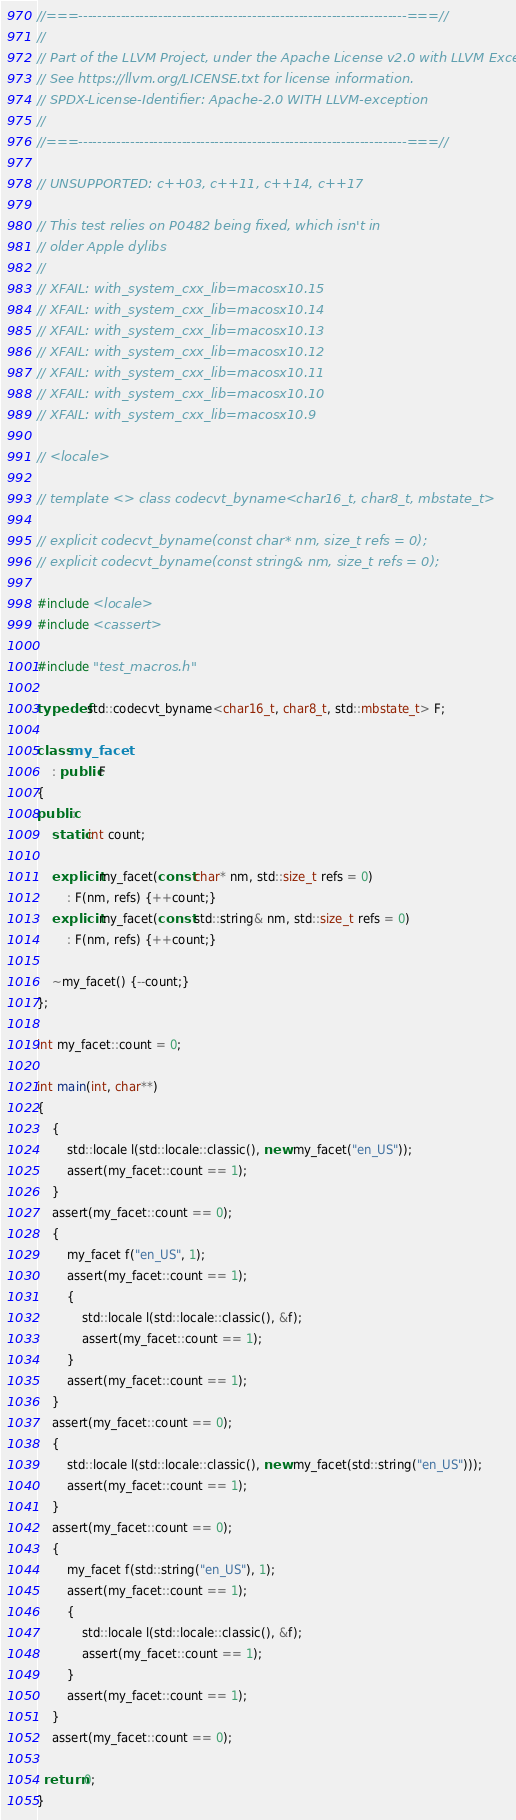<code> <loc_0><loc_0><loc_500><loc_500><_C++_>//===----------------------------------------------------------------------===//
//
// Part of the LLVM Project, under the Apache License v2.0 with LLVM Exceptions.
// See https://llvm.org/LICENSE.txt for license information.
// SPDX-License-Identifier: Apache-2.0 WITH LLVM-exception
//
//===----------------------------------------------------------------------===//

// UNSUPPORTED: c++03, c++11, c++14, c++17

// This test relies on P0482 being fixed, which isn't in
// older Apple dylibs
//
// XFAIL: with_system_cxx_lib=macosx10.15
// XFAIL: with_system_cxx_lib=macosx10.14
// XFAIL: with_system_cxx_lib=macosx10.13
// XFAIL: with_system_cxx_lib=macosx10.12
// XFAIL: with_system_cxx_lib=macosx10.11
// XFAIL: with_system_cxx_lib=macosx10.10
// XFAIL: with_system_cxx_lib=macosx10.9 

// <locale>

// template <> class codecvt_byname<char16_t, char8_t, mbstate_t>

// explicit codecvt_byname(const char* nm, size_t refs = 0);
// explicit codecvt_byname(const string& nm, size_t refs = 0);

#include <locale>
#include <cassert>

#include "test_macros.h"

typedef std::codecvt_byname<char16_t, char8_t, std::mbstate_t> F;

class my_facet
    : public F
{
public:
    static int count;

    explicit my_facet(const char* nm, std::size_t refs = 0)
        : F(nm, refs) {++count;}
    explicit my_facet(const std::string& nm, std::size_t refs = 0)
        : F(nm, refs) {++count;}

    ~my_facet() {--count;}
};

int my_facet::count = 0;

int main(int, char**)
{
    {
        std::locale l(std::locale::classic(), new my_facet("en_US"));
        assert(my_facet::count == 1);
    }
    assert(my_facet::count == 0);
    {
        my_facet f("en_US", 1);
        assert(my_facet::count == 1);
        {
            std::locale l(std::locale::classic(), &f);
            assert(my_facet::count == 1);
        }
        assert(my_facet::count == 1);
    }
    assert(my_facet::count == 0);
    {
        std::locale l(std::locale::classic(), new my_facet(std::string("en_US")));
        assert(my_facet::count == 1);
    }
    assert(my_facet::count == 0);
    {
        my_facet f(std::string("en_US"), 1);
        assert(my_facet::count == 1);
        {
            std::locale l(std::locale::classic(), &f);
            assert(my_facet::count == 1);
        }
        assert(my_facet::count == 1);
    }
    assert(my_facet::count == 0);

  return 0;
}
</code> 